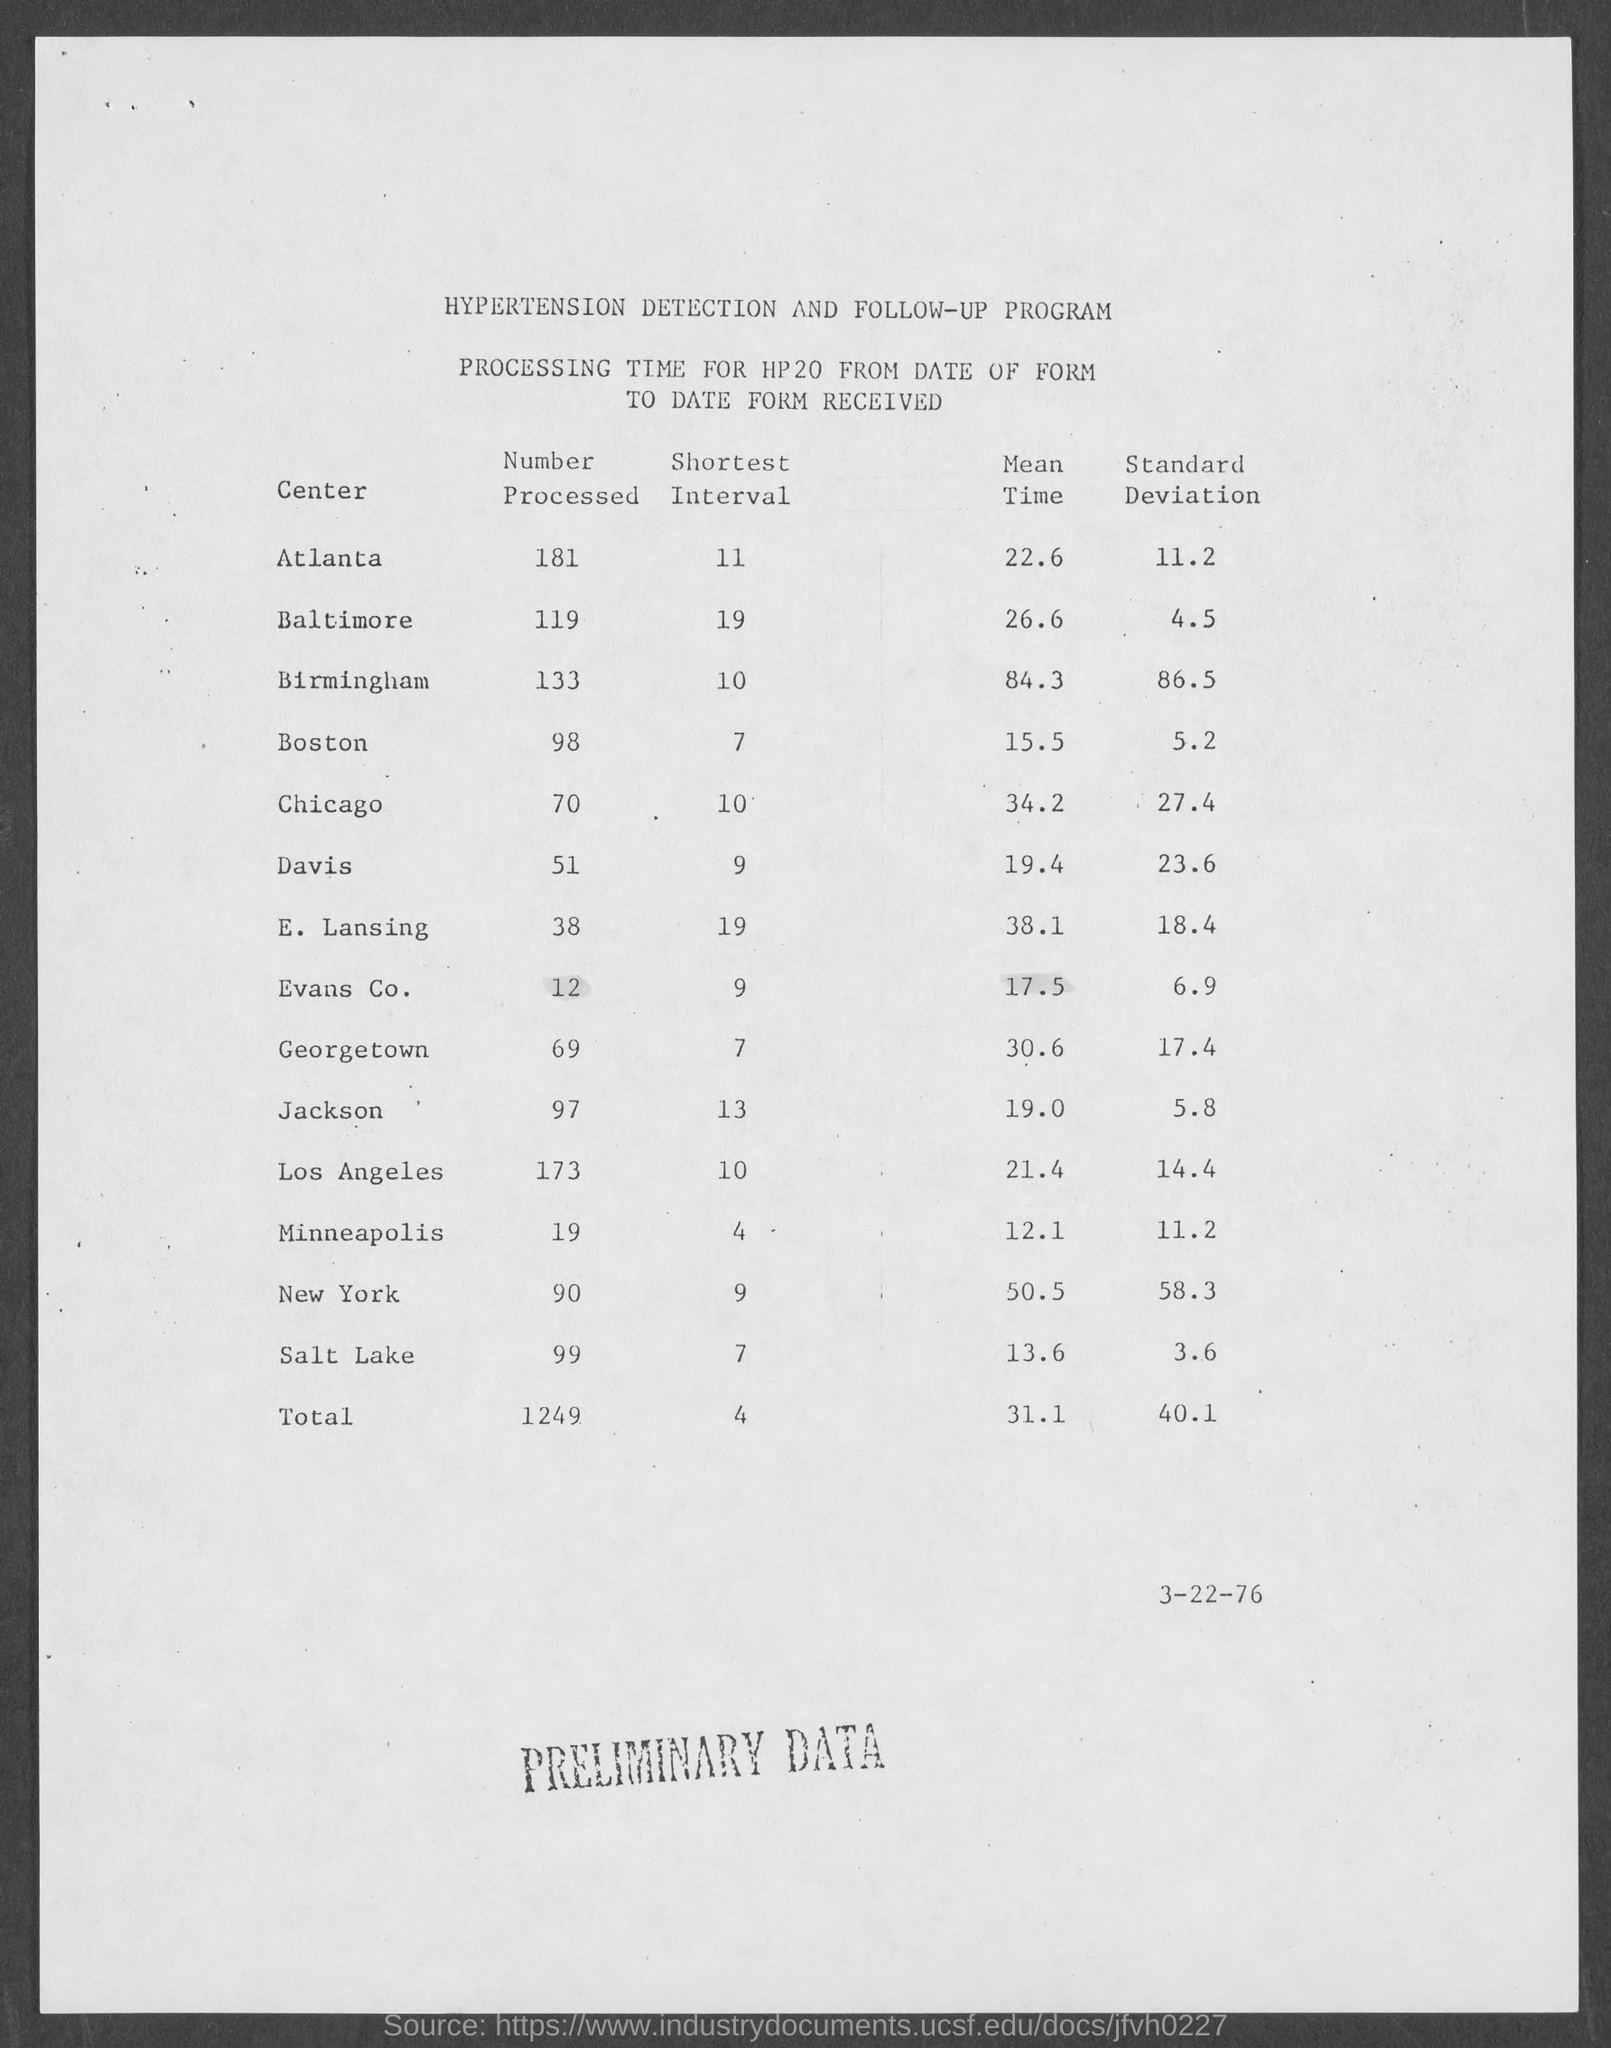Specify some key components in this picture. The Hypertension Detection and Follow-Up program is a program with a specific name. The standard deviation for Atlanta is 11.2. The mean time for Baltimore is 26.6.. What is the shortest possible interval for the Baltimore dataset? It is 19.. The number processed for Birmingham is 133. 